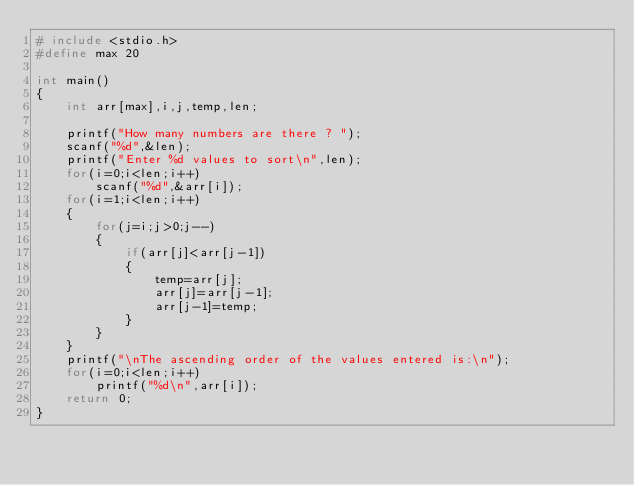<code> <loc_0><loc_0><loc_500><loc_500><_C_># include <stdio.h>
#define max 20

int main()
{
	int arr[max],i,j,temp,len;

	printf("How many numbers are there ? ");
	scanf("%d",&len);
	printf("Enter %d values to sort\n",len);
	for(i=0;i<len;i++)
		scanf("%d",&arr[i]);
	for(i=1;i<len;i++)
	{
		for(j=i;j>0;j--)
		{
			if(arr[j]<arr[j-1])
			{
				temp=arr[j];
				arr[j]=arr[j-1];
				arr[j-1]=temp;
			}
		}
	}
	printf("\nThe ascending order of the values entered is:\n");
	for(i=0;i<len;i++)
		printf("%d\n",arr[i]);
	return 0;
}
</code> 